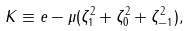Convert formula to latex. <formula><loc_0><loc_0><loc_500><loc_500>K \equiv e - \mu ( \zeta _ { 1 } ^ { 2 } + \zeta _ { 0 } ^ { 2 } + \zeta _ { - 1 } ^ { 2 } ) ,</formula> 